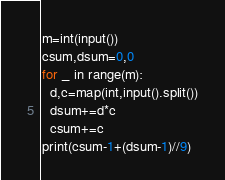Convert code to text. <code><loc_0><loc_0><loc_500><loc_500><_Python_>m=int(input())
csum,dsum=0,0
for _ in range(m):
  d,c=map(int,input().split())
  dsum+=d*c
  csum+=c
print(csum-1+(dsum-1)//9)</code> 